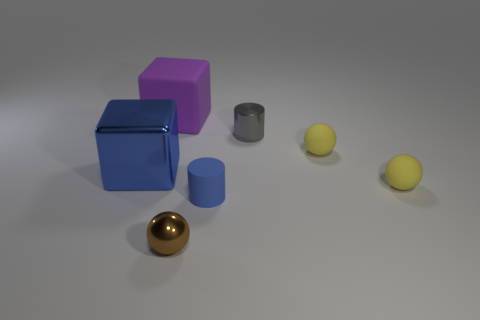The purple cube is what size?
Provide a succinct answer. Large. Is the number of tiny metal balls that are left of the big purple rubber thing greater than the number of blue rubber cylinders behind the blue matte cylinder?
Make the answer very short. No. Are there any big rubber objects behind the purple rubber block?
Offer a very short reply. No. Are there any spheres of the same size as the brown shiny object?
Make the answer very short. Yes. What color is the tiny cylinder that is the same material as the purple object?
Give a very brief answer. Blue. What material is the brown sphere?
Provide a short and direct response. Metal. The blue matte thing is what shape?
Keep it short and to the point. Cylinder. How many matte cubes have the same color as the metallic cube?
Provide a succinct answer. 0. What material is the cylinder that is to the right of the blue object that is right of the rubber object that is on the left side of the brown metallic thing made of?
Your response must be concise. Metal. What number of yellow things are either small rubber cylinders or spheres?
Offer a very short reply. 2. 